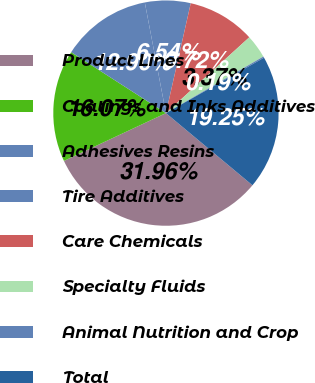<chart> <loc_0><loc_0><loc_500><loc_500><pie_chart><fcel>Product Lines<fcel>Coatings and Inks Additives<fcel>Adhesives Resins<fcel>Tire Additives<fcel>Care Chemicals<fcel>Specialty Fluids<fcel>Animal Nutrition and Crop<fcel>Total<nl><fcel>31.96%<fcel>16.07%<fcel>12.9%<fcel>6.54%<fcel>9.72%<fcel>3.37%<fcel>0.19%<fcel>19.25%<nl></chart> 